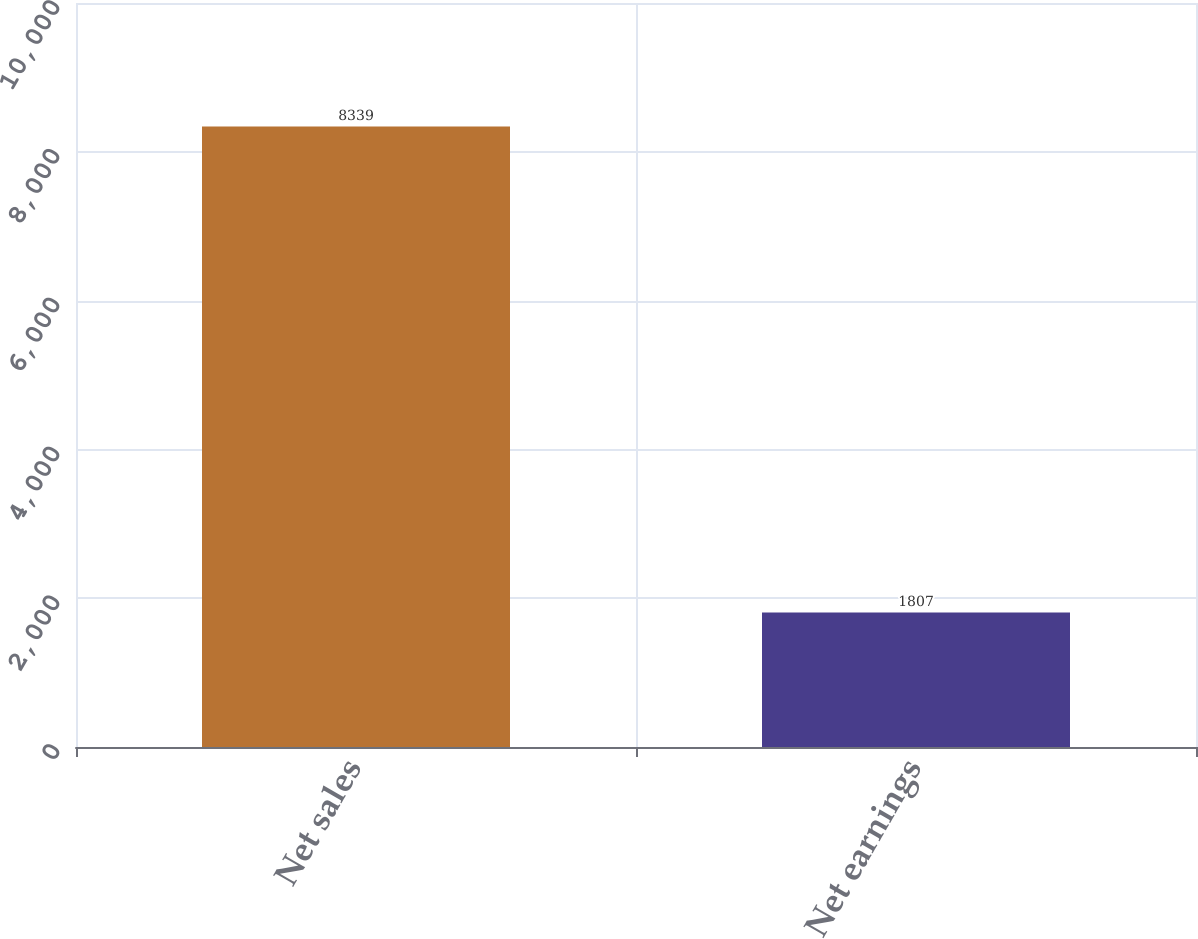Convert chart to OTSL. <chart><loc_0><loc_0><loc_500><loc_500><bar_chart><fcel>Net sales<fcel>Net earnings<nl><fcel>8339<fcel>1807<nl></chart> 